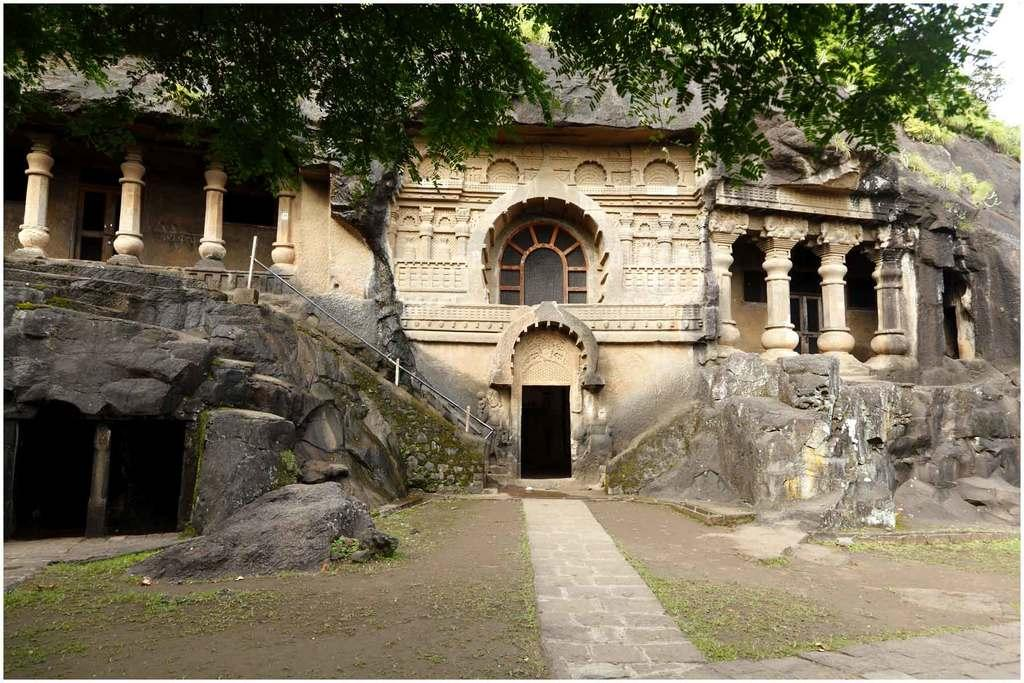What is depicted on the stone in the image? There is a building carved on a stone in the image. What features does the building have? The building has a door and a window. What else can be seen in the image besides the carved building? There is a group of poles and trees in the background of the image. What is visible in the background of the image? The sky is visible in the background of the image. What type of hair can be seen on the building in the image? There is no hair present on the building in the image; it is a carved structure. Is there a collar visible on any of the trees in the image? There is no collar present on any of the trees in the image; trees do not have collars. 